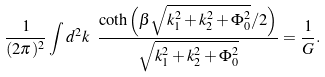<formula> <loc_0><loc_0><loc_500><loc_500>\frac { 1 } { ( 2 \pi ) ^ { 2 } } \int d ^ { 2 } k \ \frac { \coth \left ( \beta \sqrt { k _ { 1 } ^ { 2 } + k _ { 2 } ^ { 2 } + \Phi _ { 0 } ^ { 2 } } / 2 \right ) } { \sqrt { k _ { 1 } ^ { 2 } + k _ { 2 } ^ { 2 } + \Phi _ { 0 } ^ { 2 } } } = \frac { 1 } { G } .</formula> 